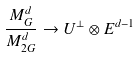<formula> <loc_0><loc_0><loc_500><loc_500>\frac { M _ { G } ^ { d } } { M _ { 2 G } ^ { d } } \rightarrow U ^ { \bot } \otimes E ^ { d - 1 }</formula> 